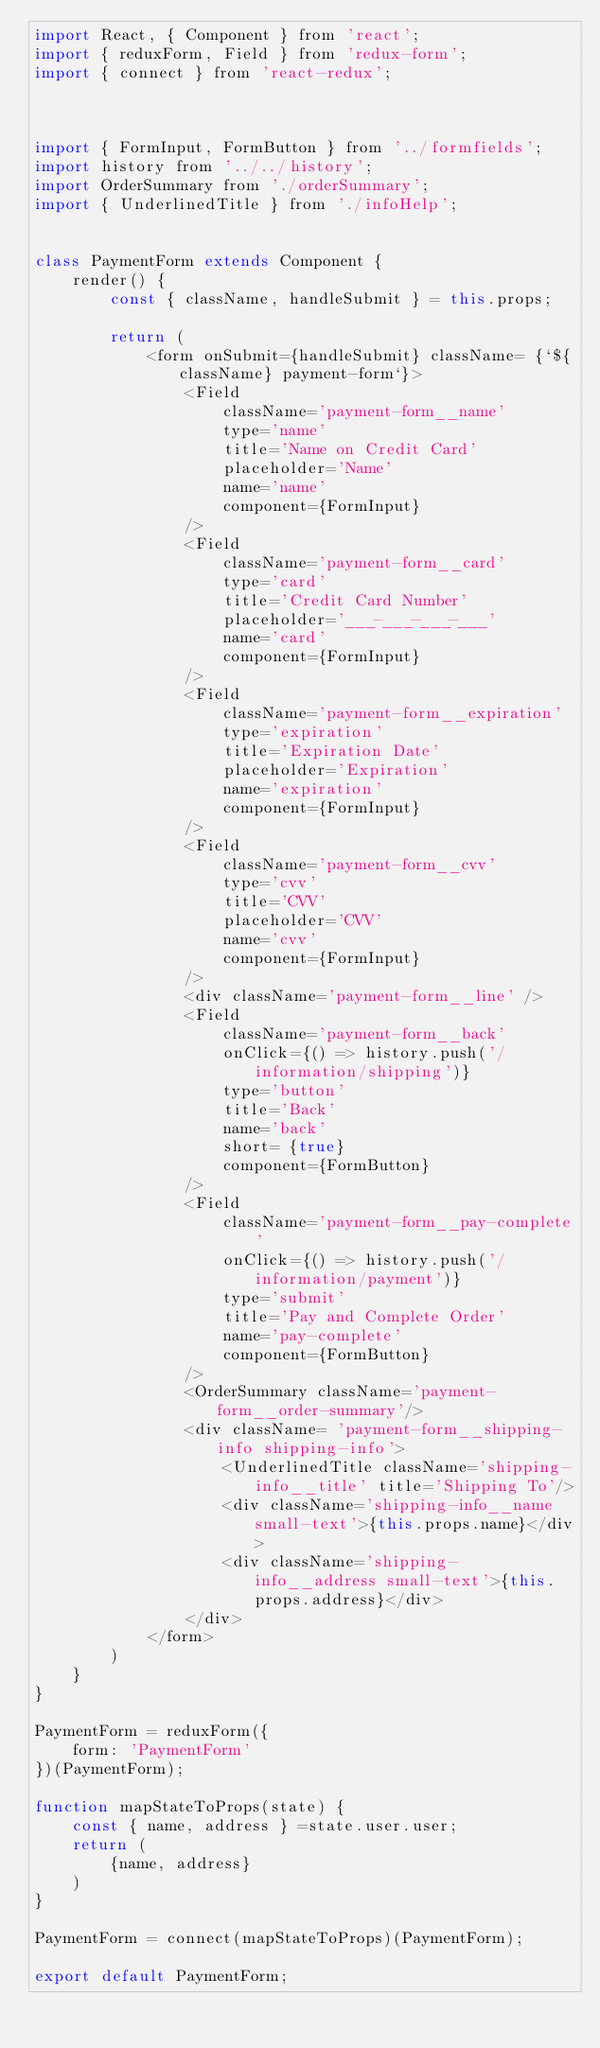<code> <loc_0><loc_0><loc_500><loc_500><_JavaScript_>import React, { Component } from 'react';
import { reduxForm, Field } from 'redux-form';
import { connect } from 'react-redux';



import { FormInput, FormButton } from '../formfields';
import history from '../../history';
import OrderSummary from './orderSummary';
import { UnderlinedTitle } from './infoHelp';


class PaymentForm extends Component {
    render() {
        const { className, handleSubmit } = this.props;

        return ( 
            <form onSubmit={handleSubmit} className= {`${className} payment-form`}> 
                <Field 
                    className='payment-form__name' 
                    type='name' 
                    title='Name on Credit Card'
                    placeholder='Name' 
                    name='name' 
                    component={FormInput}
                />
                <Field 
                    className='payment-form__card' 
                    type='card' 
                    title='Credit Card Number'
                    placeholder='___-___-___-___' 
                    name='card' 
                    component={FormInput}
                />
                <Field 
                    className='payment-form__expiration' 
                    type='expiration' 
                    title='Expiration Date'
                    placeholder='Expiration' 
                    name='expiration' 
                    component={FormInput}
                />
                <Field 
                    className='payment-form__cvv' 
                    type='cvv' 
                    title='CVV'
                    placeholder='CVV' 
                    name='cvv' 
                    component={FormInput}
                /> 
                <div className='payment-form__line' />
                <Field 
                    className='payment-form__back' 
                    onClick={() => history.push('/information/shipping')}
                    type='button' 
                    title='Back' 
                    name='back' 
                    short= {true}
                    component={FormButton}
                /> 
                <Field 
                    className='payment-form__pay-complete' 
                    onClick={() => history.push('/information/payment')}
                    type='submit' 
                    title='Pay and Complete Order' 
                    name='pay-complete' 
                    component={FormButton}
                />              
                <OrderSummary className='payment-form__order-summary'/>
                <div className= 'payment-form__shipping-info shipping-info'>
                    <UnderlinedTitle className='shipping-info__title' title='Shipping To'/>
                    <div className='shipping-info__name small-text'>{this.props.name}</div>
                    <div className='shipping-info__address small-text'>{this.props.address}</div>
                </div>
            </form>
        )
    }
}

PaymentForm = reduxForm({
    form: 'PaymentForm'
})(PaymentForm);

function mapStateToProps(state) {
    const { name, address } =state.user.user;
    return (
        {name, address}
    )
}

PaymentForm = connect(mapStateToProps)(PaymentForm);

export default PaymentForm;</code> 